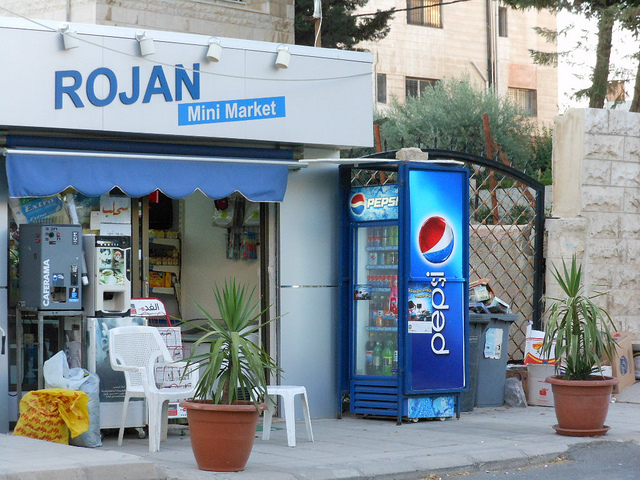How many potted plants are there? 2 